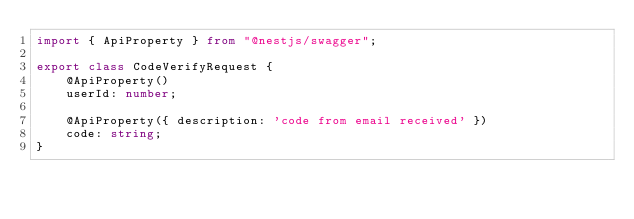<code> <loc_0><loc_0><loc_500><loc_500><_TypeScript_>import { ApiProperty } from "@nestjs/swagger";

export class CodeVerifyRequest {
    @ApiProperty()
    userId: number;

    @ApiProperty({ description: 'code from email received' })
    code: string;
}</code> 